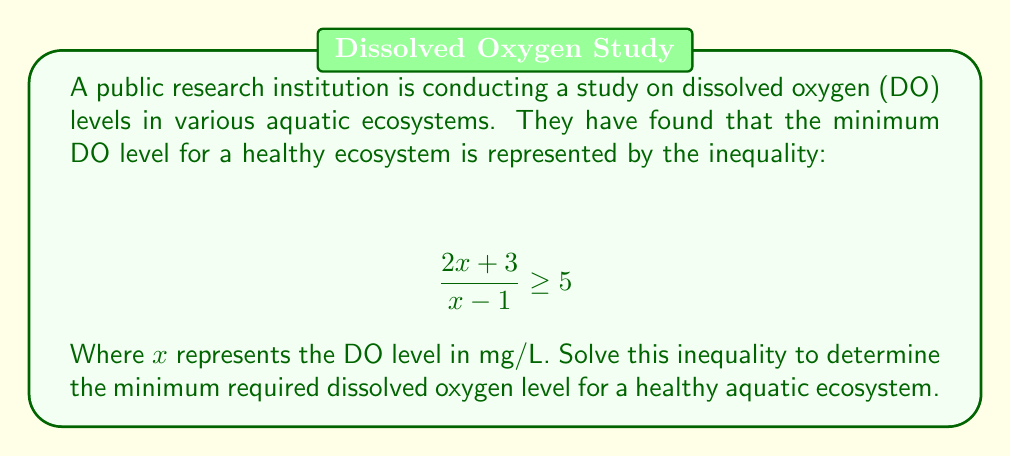Teach me how to tackle this problem. 1) Start with the given inequality:
   $$ \frac{2x + 3}{x - 1} \geq 5 $$

2) Multiply both sides by $(x - 1)$, noting that this operation may flip the inequality if $(x - 1)$ is negative:
   $$ 2x + 3 \geq 5(x - 1) \text{ for } x > 1 $$
   $$ 2x + 3 \leq 5(x - 1) \text{ for } x < 1 $$

3) Expand the right side:
   $$ 2x + 3 \geq 5x - 5 \text{ for } x > 1 $$
   $$ 2x + 3 \leq 5x - 5 \text{ for } x < 1 $$

4) Subtract $2x$ from both sides:
   $$ 3 \geq 3x - 5 \text{ for } x > 1 $$
   $$ 3 \leq 3x - 5 \text{ for } x < 1 $$

5) Add 5 to both sides:
   $$ 8 \geq 3x \text{ for } x > 1 $$
   $$ 8 \leq 3x \text{ for } x < 1 $$

6) Divide by 3:
   $$ \frac{8}{3} \geq x \text{ for } x > 1 $$
   $$ \frac{8}{3} \leq x \text{ for } x < 1 $$

7) Combine the inequalities:
   $$ x \geq \frac{8}{3} $$

Therefore, the minimum required dissolved oxygen level is $\frac{8}{3}$ mg/L or approximately 2.67 mg/L.
Answer: $\frac{8}{3}$ mg/L 